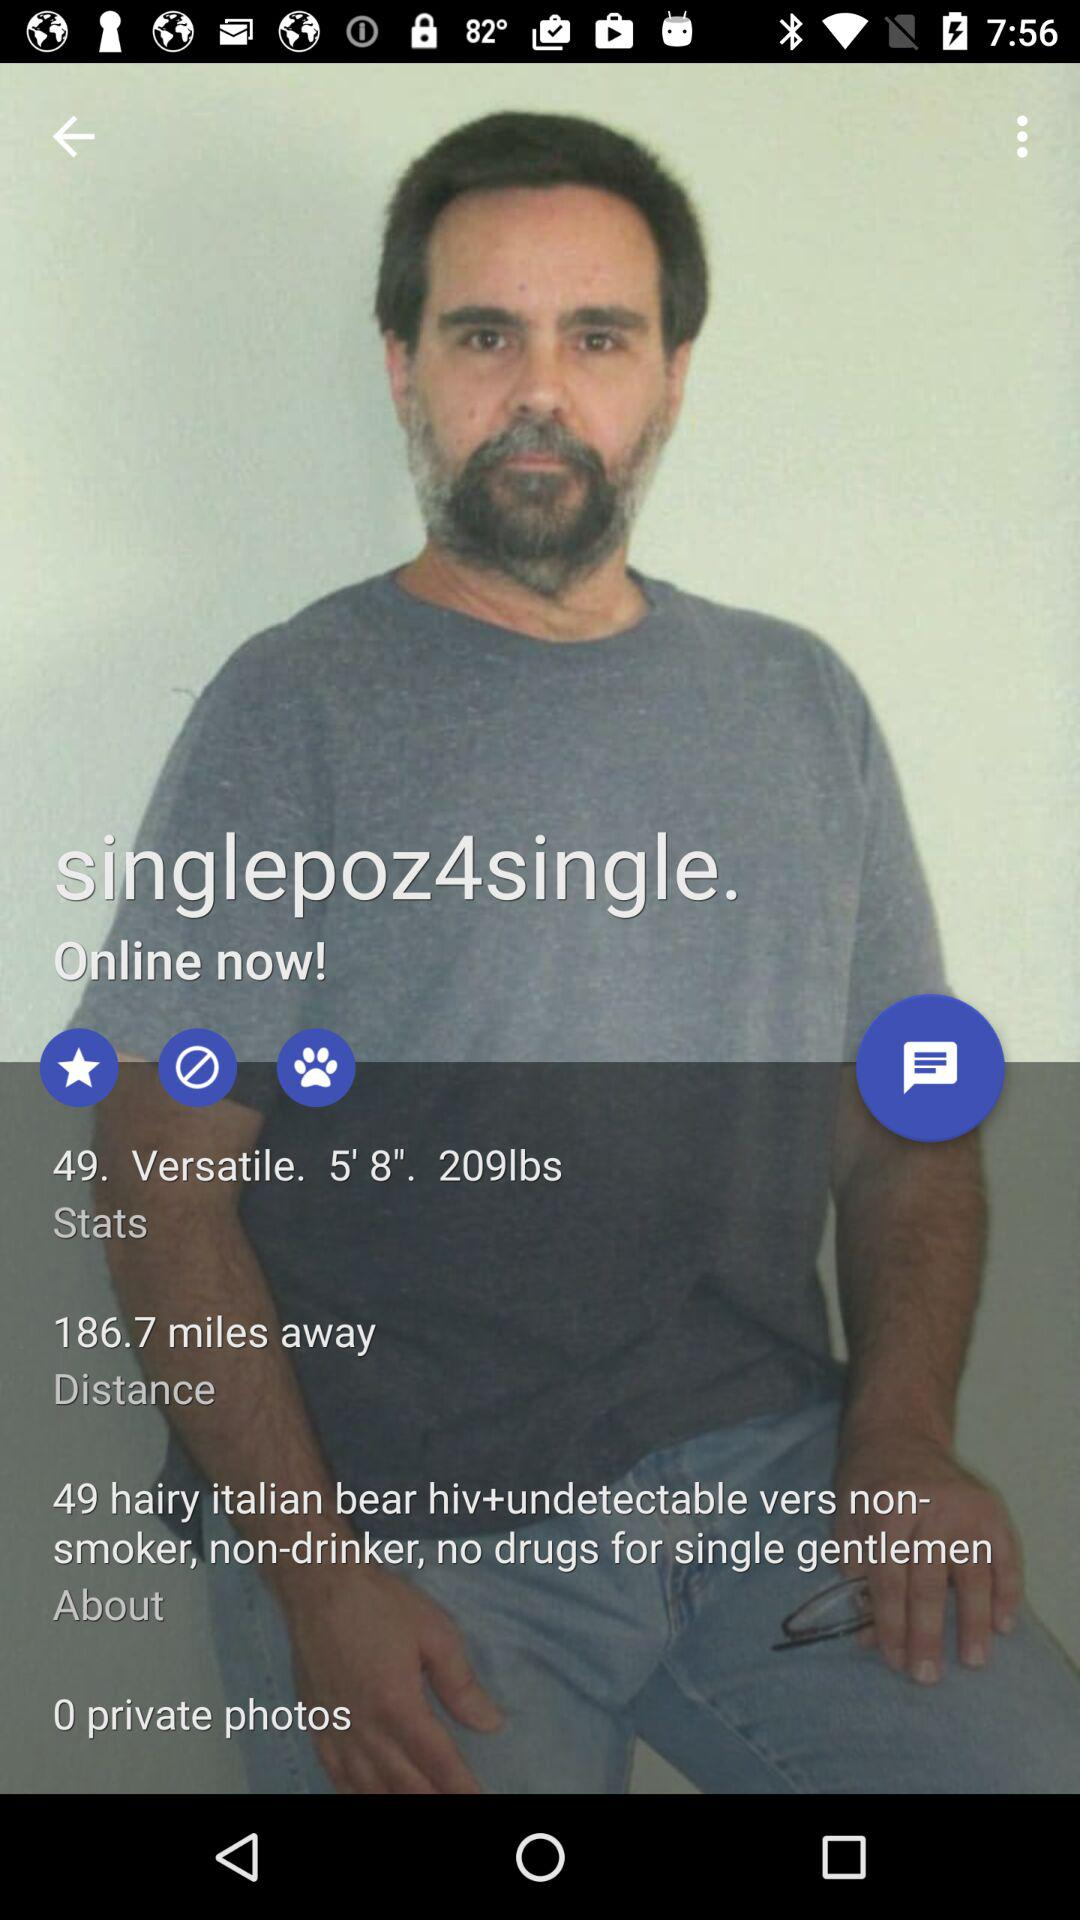What is the height of the man? The height is 5 feet 8 inches. 